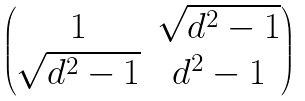Convert formula to latex. <formula><loc_0><loc_0><loc_500><loc_500>\begin{pmatrix} 1 & \sqrt { d ^ { 2 } - 1 } \\ \sqrt { d ^ { 2 } - 1 } & d ^ { 2 } - 1 \end{pmatrix}</formula> 